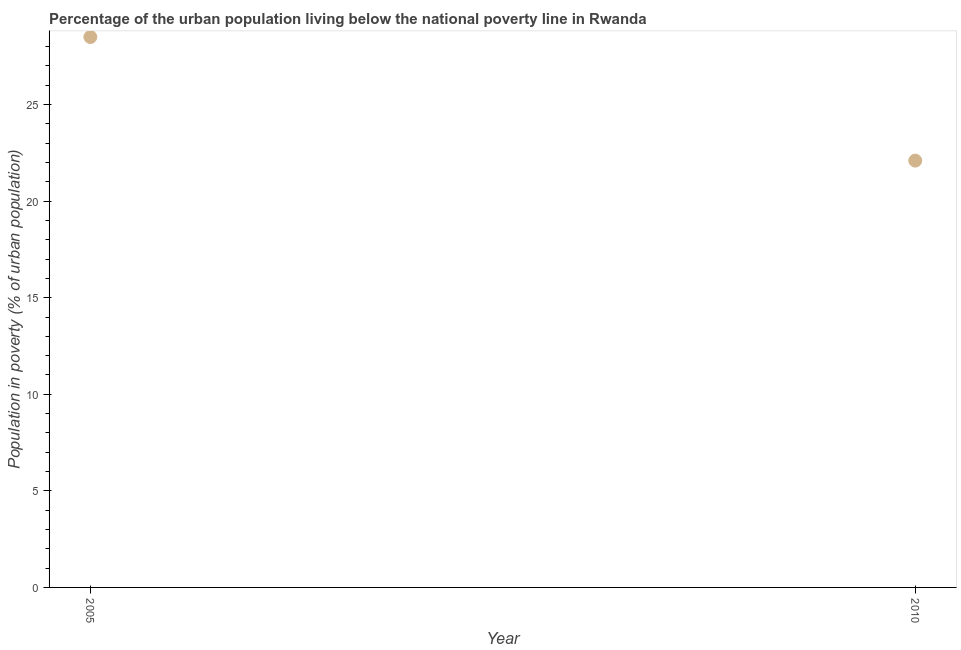Across all years, what is the minimum percentage of urban population living below poverty line?
Your response must be concise. 22.1. What is the sum of the percentage of urban population living below poverty line?
Ensure brevity in your answer.  50.6. What is the difference between the percentage of urban population living below poverty line in 2005 and 2010?
Make the answer very short. 6.4. What is the average percentage of urban population living below poverty line per year?
Your answer should be compact. 25.3. What is the median percentage of urban population living below poverty line?
Your answer should be compact. 25.3. In how many years, is the percentage of urban population living below poverty line greater than 24 %?
Make the answer very short. 1. What is the ratio of the percentage of urban population living below poverty line in 2005 to that in 2010?
Make the answer very short. 1.29. How many dotlines are there?
Provide a succinct answer. 1. How many years are there in the graph?
Your answer should be compact. 2. Are the values on the major ticks of Y-axis written in scientific E-notation?
Provide a short and direct response. No. Does the graph contain any zero values?
Make the answer very short. No. What is the title of the graph?
Your response must be concise. Percentage of the urban population living below the national poverty line in Rwanda. What is the label or title of the Y-axis?
Ensure brevity in your answer.  Population in poverty (% of urban population). What is the Population in poverty (% of urban population) in 2010?
Your answer should be compact. 22.1. What is the difference between the Population in poverty (% of urban population) in 2005 and 2010?
Offer a very short reply. 6.4. What is the ratio of the Population in poverty (% of urban population) in 2005 to that in 2010?
Make the answer very short. 1.29. 